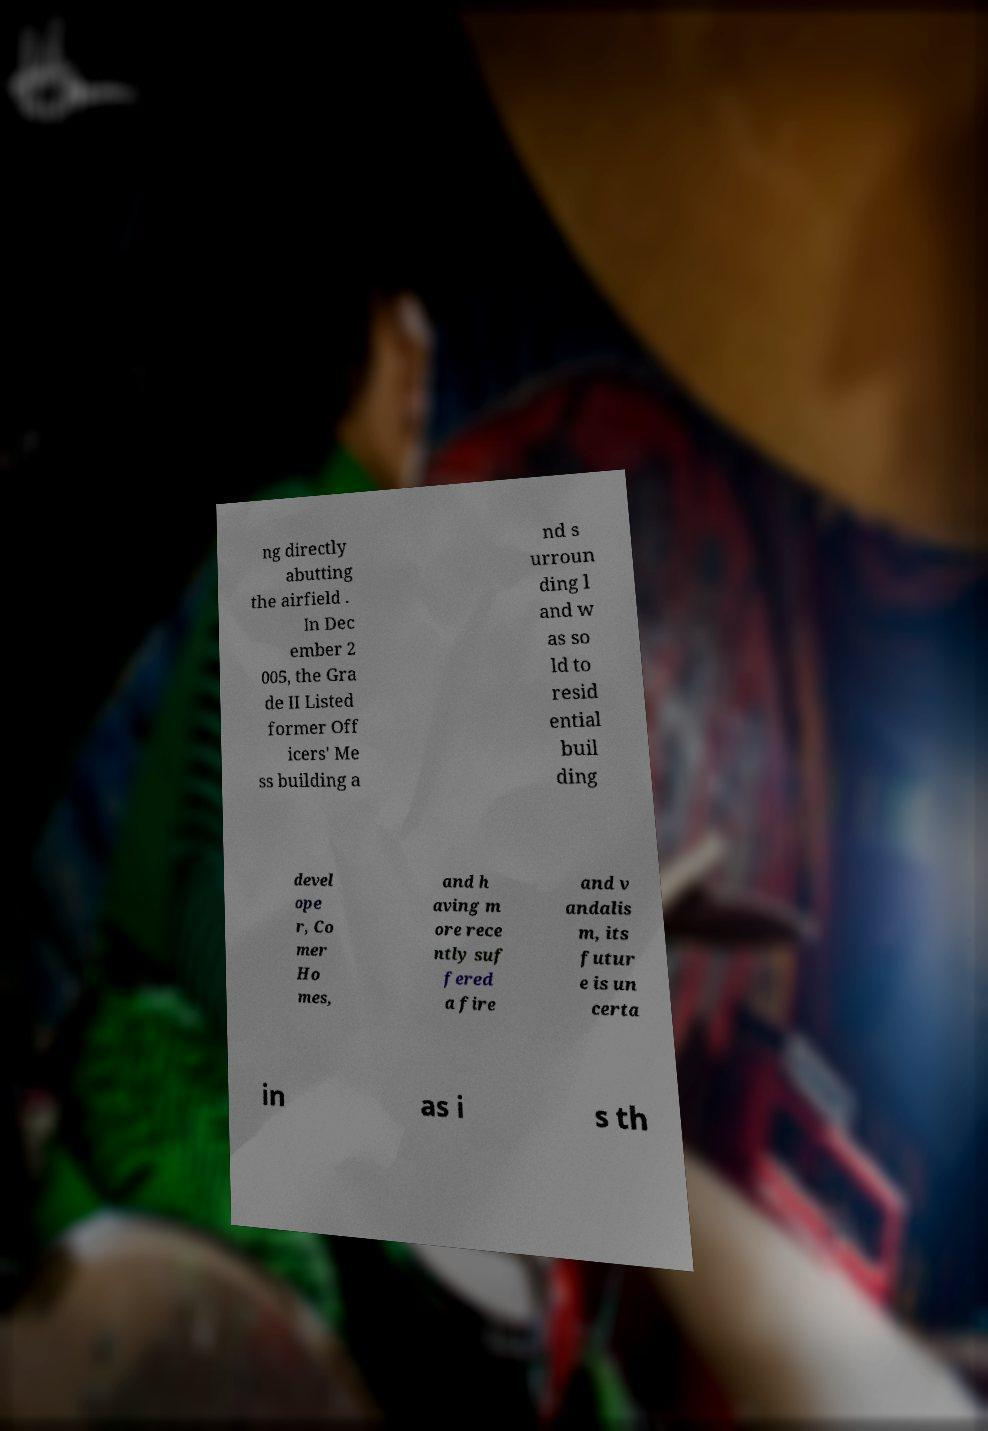Can you accurately transcribe the text from the provided image for me? ng directly abutting the airfield . In Dec ember 2 005, the Gra de II Listed former Off icers' Me ss building a nd s urroun ding l and w as so ld to resid ential buil ding devel ope r, Co mer Ho mes, and h aving m ore rece ntly suf fered a fire and v andalis m, its futur e is un certa in as i s th 